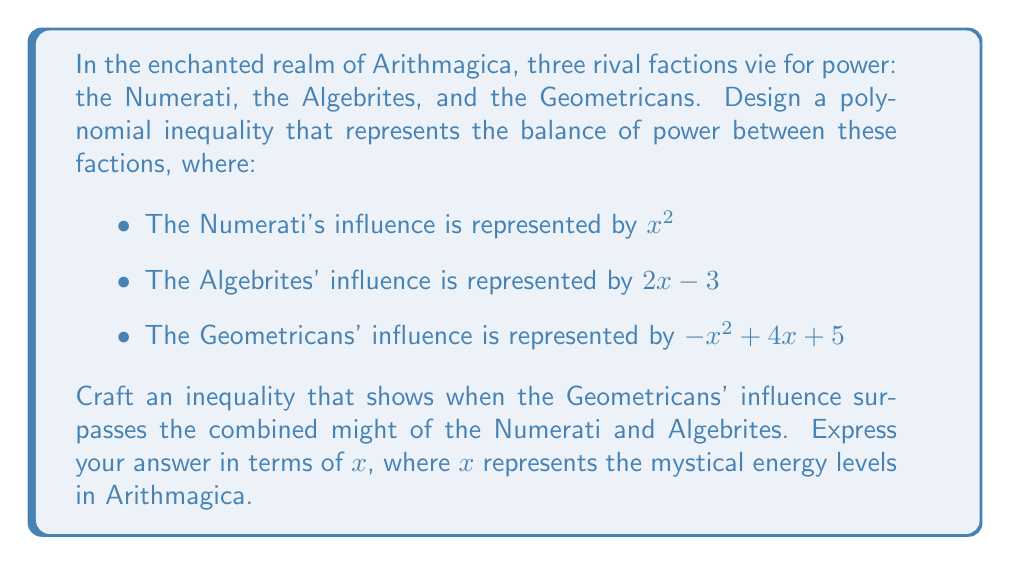Solve this math problem. Let's approach this magical conundrum step by step:

1) First, we need to express the combined influence of the Numerati and Algebrites:
   Numerati + Algebrites = $x^2 + (2x - 3)$ = $x^2 + 2x - 3$

2) Now, we want to find when the Geometricans' influence is greater than this combined influence:
   $-x^2 + 4x + 5 > x^2 + 2x - 3$

3) Let's solve this inequality:
   $-x^2 + 4x + 5 > x^2 + 2x - 3$
   $-x^2 + 4x + 5 - (x^2 + 2x - 3) > 0$
   $-2x^2 + 2x + 8 > 0$

4) Dividing everything by -2 (which flips the inequality sign):
   $x^2 - x - 4 < 0$

5) This is a quadratic inequality. To solve it, we need to find the roots of the quadratic equation $x^2 - x - 4 = 0$:
   
   Using the quadratic formula: $x = \frac{-b \pm \sqrt{b^2 - 4ac}}{2a}$
   
   $x = \frac{1 \pm \sqrt{1^2 - 4(1)(-4)}}{2(1)} = \frac{1 \pm \sqrt{17}}{2}$

6) The roots are:
   $x_1 = \frac{1 + \sqrt{17}}{2} \approx 2.56$
   $x_2 = \frac{1 - \sqrt{17}}{2} \approx -1.56$

7) The parabola opens upward (coefficient of $x^2$ is positive), so the inequality $x^2 - x - 4 < 0$ is satisfied between these two roots.

Therefore, the Geometricans' influence surpasses the combined might of the Numerati and Algebrites when:

$$\frac{1 - \sqrt{17}}{2} < x < \frac{1 + \sqrt{17}}{2}$$
Answer: $\frac{1 - \sqrt{17}}{2} < x < \frac{1 + \sqrt{17}}{2}$ 